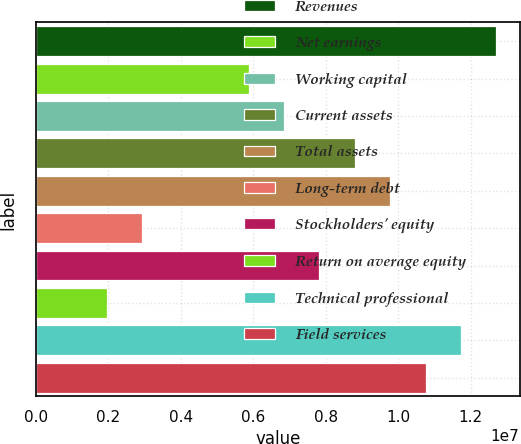<chart> <loc_0><loc_0><loc_500><loc_500><bar_chart><fcel>Revenues<fcel>Net earnings<fcel>Working capital<fcel>Current assets<fcel>Total assets<fcel>Long-term debt<fcel>Stockholders' equity<fcel>Return on average equity<fcel>Technical professional<fcel>Field services<nl><fcel>1.2711e+07<fcel>5.86662e+06<fcel>6.84439e+06<fcel>8.79993e+06<fcel>9.7777e+06<fcel>2.93331e+06<fcel>7.82216e+06<fcel>1.95554e+06<fcel>1.17332e+07<fcel>1.07555e+07<nl></chart> 